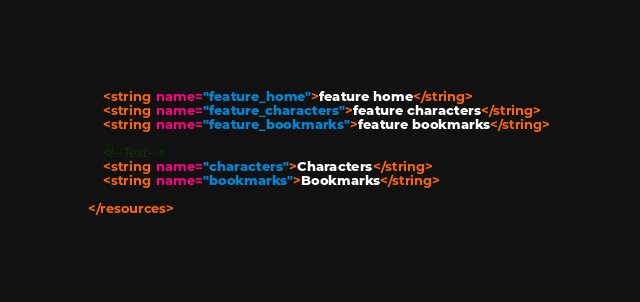Convert code to text. <code><loc_0><loc_0><loc_500><loc_500><_XML_>    <string name="feature_home">feature home</string>
    <string name="feature_characters">feature characters</string>
    <string name="feature_bookmarks">feature bookmarks</string>

    <!--Text-->
    <string name="characters">Characters</string>
    <string name="bookmarks">Bookmarks</string>

</resources></code> 